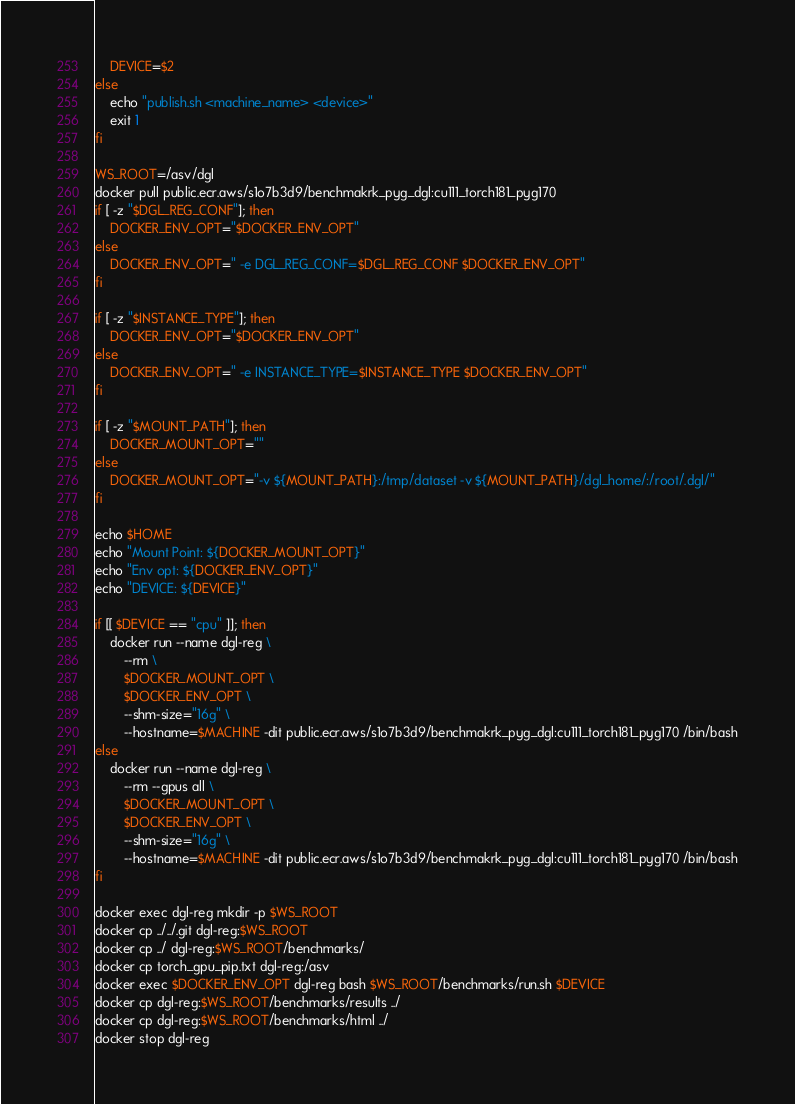<code> <loc_0><loc_0><loc_500><loc_500><_Bash_>    DEVICE=$2
else
    echo "publish.sh <machine_name> <device>"
    exit 1
fi

WS_ROOT=/asv/dgl
docker pull public.ecr.aws/s1o7b3d9/benchmakrk_pyg_dgl:cu111_torch181_pyg170
if [ -z "$DGL_REG_CONF"]; then
    DOCKER_ENV_OPT="$DOCKER_ENV_OPT"
else
    DOCKER_ENV_OPT=" -e DGL_REG_CONF=$DGL_REG_CONF $DOCKER_ENV_OPT"
fi

if [ -z "$INSTANCE_TYPE"]; then
    DOCKER_ENV_OPT="$DOCKER_ENV_OPT"
else
    DOCKER_ENV_OPT=" -e INSTANCE_TYPE=$INSTANCE_TYPE $DOCKER_ENV_OPT"
fi

if [ -z "$MOUNT_PATH"]; then
    DOCKER_MOUNT_OPT=""
else
    DOCKER_MOUNT_OPT="-v ${MOUNT_PATH}:/tmp/dataset -v ${MOUNT_PATH}/dgl_home/:/root/.dgl/"
fi

echo $HOME
echo "Mount Point: ${DOCKER_MOUNT_OPT}"
echo "Env opt: ${DOCKER_ENV_OPT}"
echo "DEVICE: ${DEVICE}"

if [[ $DEVICE == "cpu" ]]; then
    docker run --name dgl-reg \
        --rm \
        $DOCKER_MOUNT_OPT \
        $DOCKER_ENV_OPT \
        --shm-size="16g" \
        --hostname=$MACHINE -dit public.ecr.aws/s1o7b3d9/benchmakrk_pyg_dgl:cu111_torch181_pyg170 /bin/bash
else
    docker run --name dgl-reg \
        --rm --gpus all \
        $DOCKER_MOUNT_OPT \
        $DOCKER_ENV_OPT \
        --shm-size="16g" \
        --hostname=$MACHINE -dit public.ecr.aws/s1o7b3d9/benchmakrk_pyg_dgl:cu111_torch181_pyg170 /bin/bash
fi

docker exec dgl-reg mkdir -p $WS_ROOT
docker cp ../../.git dgl-reg:$WS_ROOT
docker cp ../ dgl-reg:$WS_ROOT/benchmarks/
docker cp torch_gpu_pip.txt dgl-reg:/asv
docker exec $DOCKER_ENV_OPT dgl-reg bash $WS_ROOT/benchmarks/run.sh $DEVICE
docker cp dgl-reg:$WS_ROOT/benchmarks/results ../
docker cp dgl-reg:$WS_ROOT/benchmarks/html ../
docker stop dgl-reg
</code> 